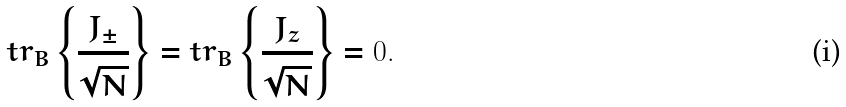Convert formula to latex. <formula><loc_0><loc_0><loc_500><loc_500>t r _ { B } \left \{ \frac { J _ { \pm } } { \sqrt { N } } \right \} = t r _ { B } \left \{ \frac { J _ { z } } { \sqrt { N } } \right \} = 0 .</formula> 